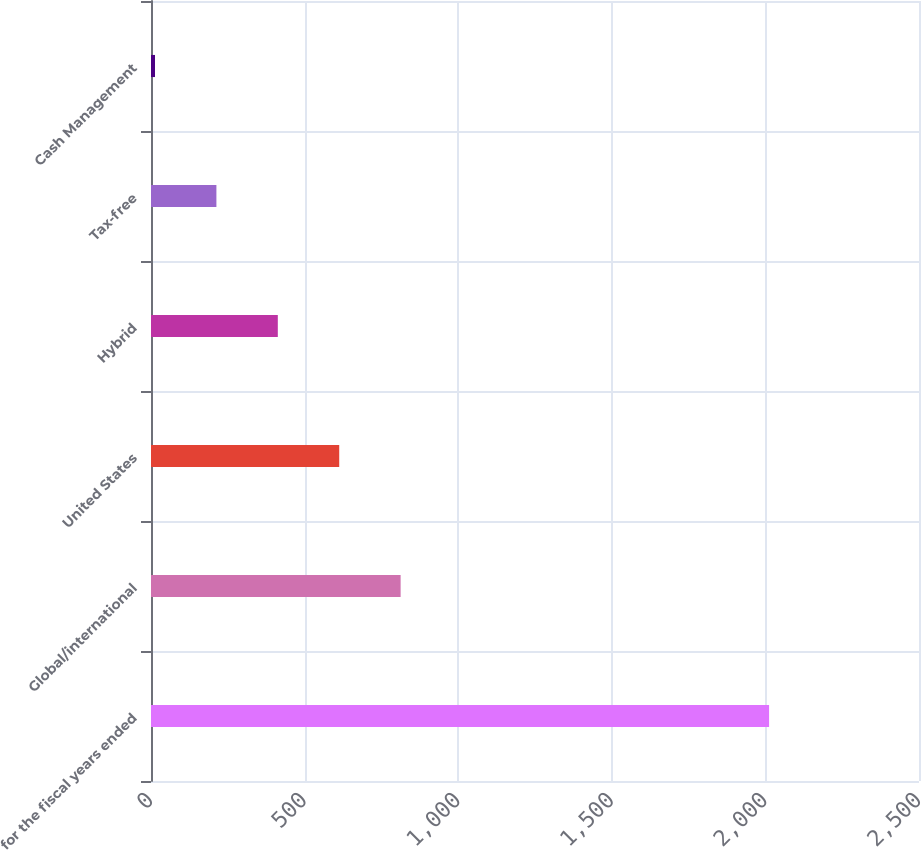Convert chart. <chart><loc_0><loc_0><loc_500><loc_500><bar_chart><fcel>for the fiscal years ended<fcel>Global/international<fcel>United States<fcel>Hybrid<fcel>Tax-free<fcel>Cash Management<nl><fcel>2012<fcel>812.6<fcel>612.7<fcel>412.8<fcel>212.9<fcel>13<nl></chart> 